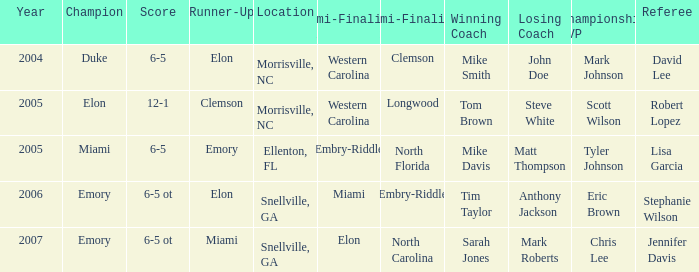List the scores of all games when Miami were listed as the first Semi finalist 6-5 ot. 